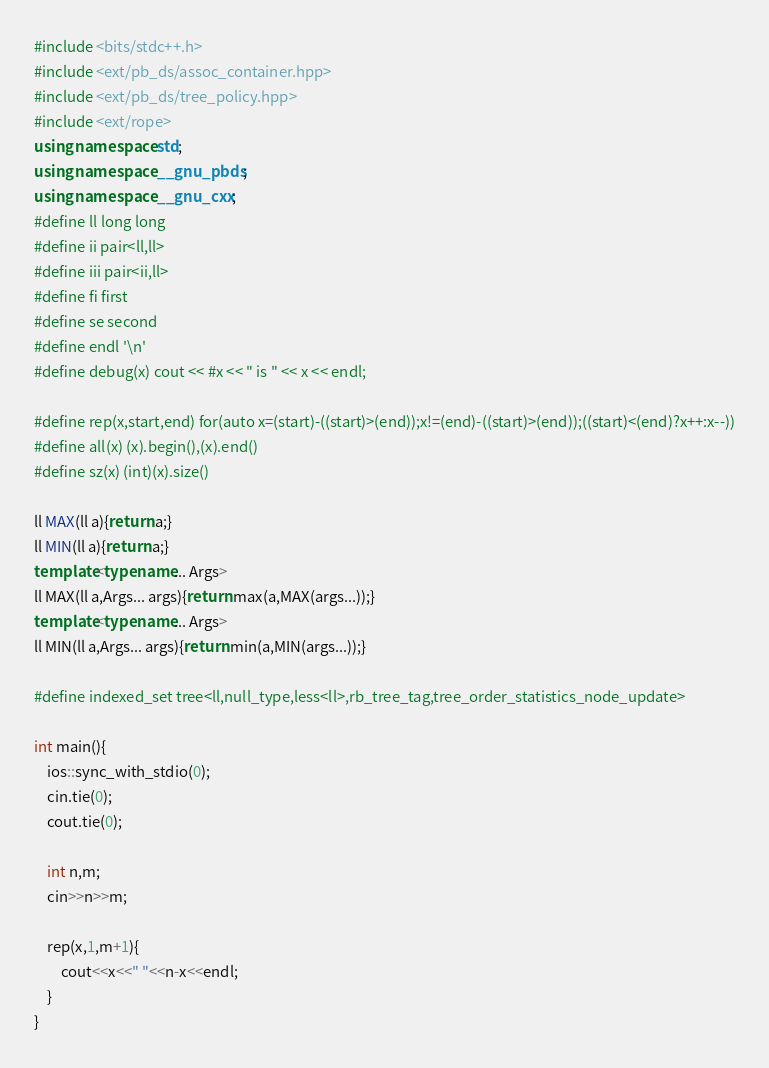Convert code to text. <code><loc_0><loc_0><loc_500><loc_500><_C++_>#include <bits/stdc++.h>
#include <ext/pb_ds/assoc_container.hpp>
#include <ext/pb_ds/tree_policy.hpp>
#include <ext/rope>
using namespace std;
using namespace __gnu_pbds;
using namespace __gnu_cxx;
#define ll long long
#define ii pair<ll,ll>
#define iii pair<ii,ll>
#define fi first
#define se second
#define endl '\n'
#define debug(x) cout << #x << " is " << x << endl;

#define rep(x,start,end) for(auto x=(start)-((start)>(end));x!=(end)-((start)>(end));((start)<(end)?x++:x--))
#define all(x) (x).begin(),(x).end()
#define sz(x) (int)(x).size()

ll MAX(ll a){return a;}
ll MIN(ll a){return a;}
template<typename... Args>
ll MAX(ll a,Args... args){return max(a,MAX(args...));}
template<typename... Args>
ll MIN(ll a,Args... args){return min(a,MIN(args...));}

#define indexed_set tree<ll,null_type,less<ll>,rb_tree_tag,tree_order_statistics_node_update>

int main(){
	ios::sync_with_stdio(0);
	cin.tie(0);
	cout.tie(0);
	
	int n,m;
	cin>>n>>m;
	
	rep(x,1,m+1){
		cout<<x<<" "<<n-x<<endl;
	}
}
</code> 